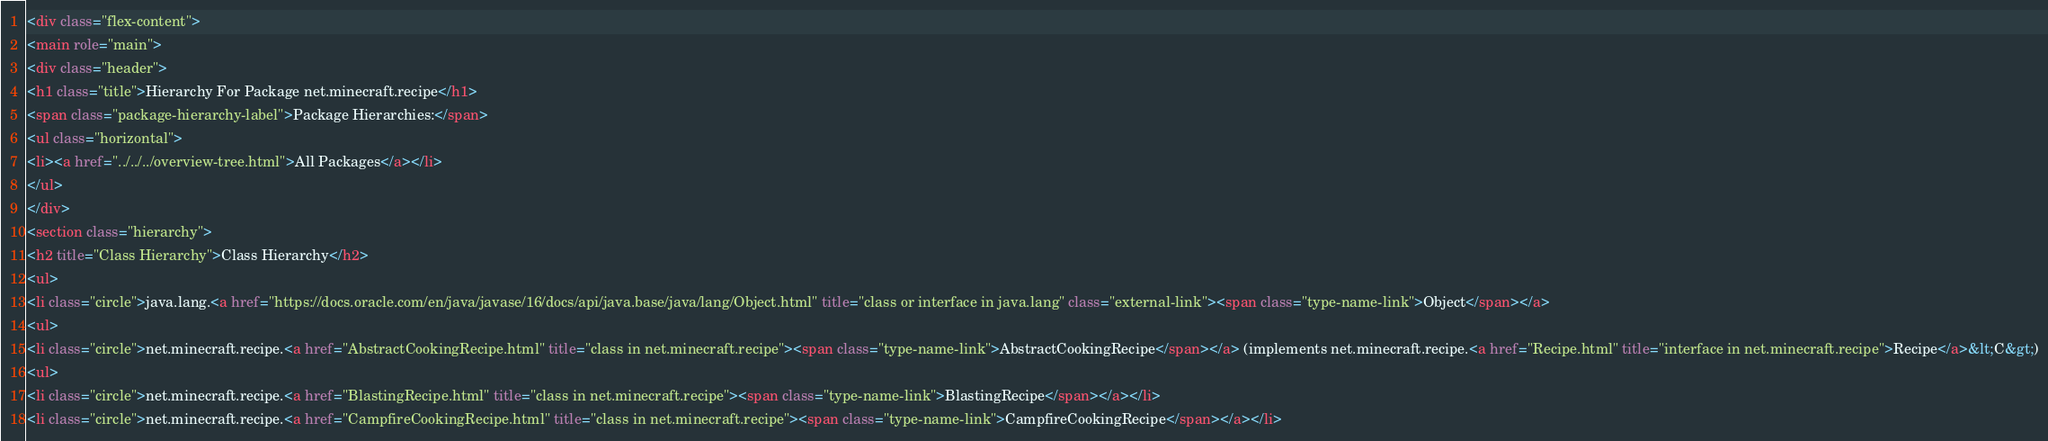Convert code to text. <code><loc_0><loc_0><loc_500><loc_500><_HTML_><div class="flex-content">
<main role="main">
<div class="header">
<h1 class="title">Hierarchy For Package net.minecraft.recipe</h1>
<span class="package-hierarchy-label">Package Hierarchies:</span>
<ul class="horizontal">
<li><a href="../../../overview-tree.html">All Packages</a></li>
</ul>
</div>
<section class="hierarchy">
<h2 title="Class Hierarchy">Class Hierarchy</h2>
<ul>
<li class="circle">java.lang.<a href="https://docs.oracle.com/en/java/javase/16/docs/api/java.base/java/lang/Object.html" title="class or interface in java.lang" class="external-link"><span class="type-name-link">Object</span></a>
<ul>
<li class="circle">net.minecraft.recipe.<a href="AbstractCookingRecipe.html" title="class in net.minecraft.recipe"><span class="type-name-link">AbstractCookingRecipe</span></a> (implements net.minecraft.recipe.<a href="Recipe.html" title="interface in net.minecraft.recipe">Recipe</a>&lt;C&gt;)
<ul>
<li class="circle">net.minecraft.recipe.<a href="BlastingRecipe.html" title="class in net.minecraft.recipe"><span class="type-name-link">BlastingRecipe</span></a></li>
<li class="circle">net.minecraft.recipe.<a href="CampfireCookingRecipe.html" title="class in net.minecraft.recipe"><span class="type-name-link">CampfireCookingRecipe</span></a></li></code> 